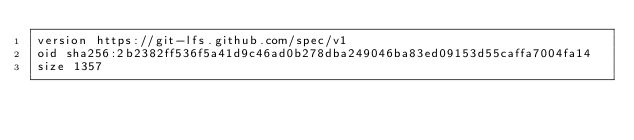Convert code to text. <code><loc_0><loc_0><loc_500><loc_500><_C++_>version https://git-lfs.github.com/spec/v1
oid sha256:2b2382ff536f5a41d9c46ad0b278dba249046ba83ed09153d55caffa7004fa14
size 1357
</code> 